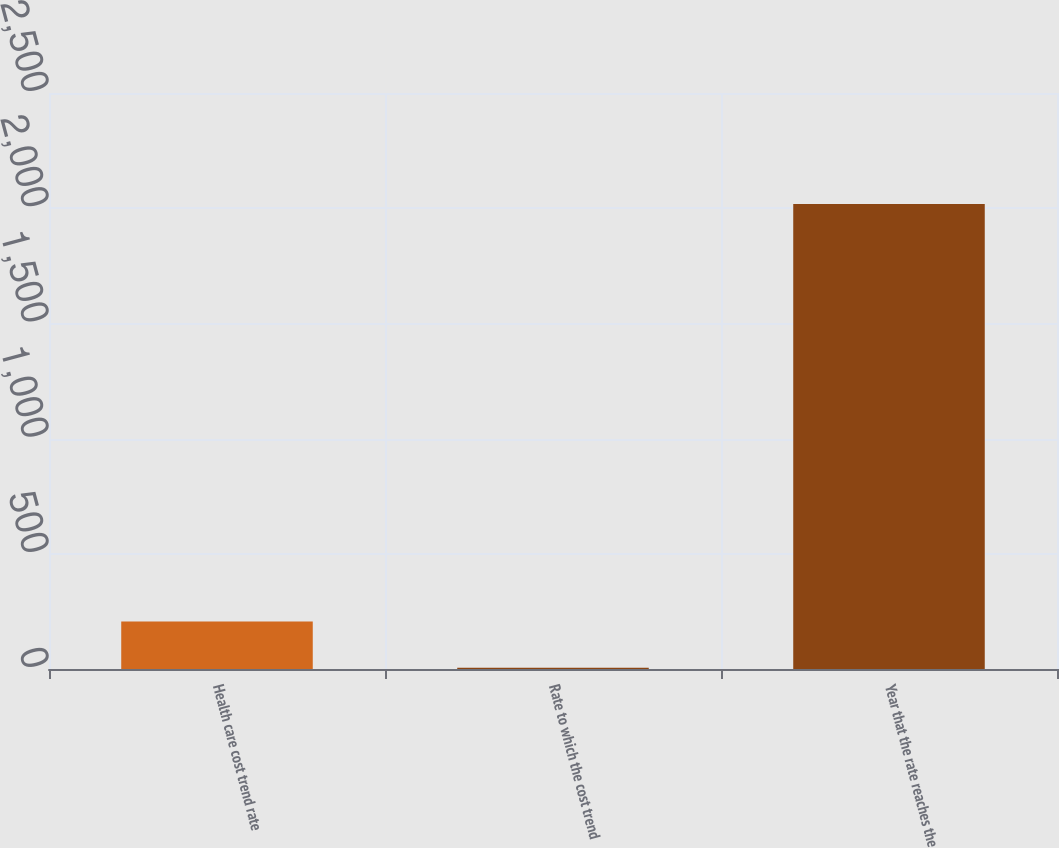Convert chart to OTSL. <chart><loc_0><loc_0><loc_500><loc_500><bar_chart><fcel>Health care cost trend rate<fcel>Rate to which the cost trend<fcel>Year that the rate reaches the<nl><fcel>206.3<fcel>5<fcel>2018<nl></chart> 